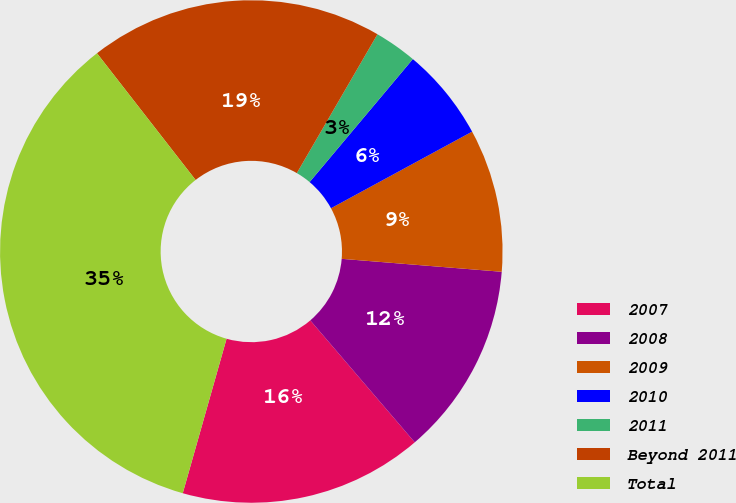Convert chart to OTSL. <chart><loc_0><loc_0><loc_500><loc_500><pie_chart><fcel>2007<fcel>2008<fcel>2009<fcel>2010<fcel>2011<fcel>Beyond 2011<fcel>Total<nl><fcel>15.67%<fcel>12.44%<fcel>9.2%<fcel>5.97%<fcel>2.74%<fcel>18.9%<fcel>35.07%<nl></chart> 